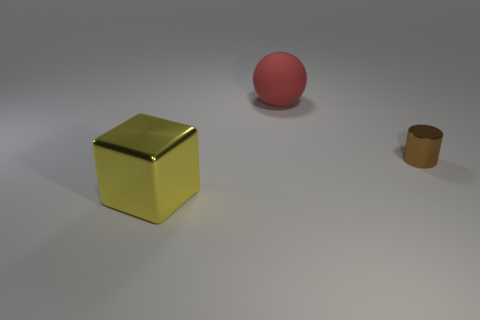Does the large block have the same material as the brown cylinder?
Make the answer very short. Yes. Are there any big rubber objects that are behind the large thing behind the metal block?
Your answer should be very brief. No. Are there any tiny yellow matte objects of the same shape as the red object?
Your answer should be compact. No. Does the cube have the same color as the rubber ball?
Provide a succinct answer. No. What material is the large object in front of the shiny thing that is on the right side of the large yellow metallic thing?
Offer a very short reply. Metal. What size is the red matte sphere?
Ensure brevity in your answer.  Large. What is the size of the cylinder that is the same material as the large cube?
Offer a terse response. Small. Is the size of the shiny object right of the yellow thing the same as the rubber ball?
Your response must be concise. No. The metal thing that is behind the metal thing that is in front of the small brown metallic thing on the right side of the matte sphere is what shape?
Give a very brief answer. Cylinder. What number of things are yellow shiny cubes or metal things on the right side of the big yellow block?
Provide a succinct answer. 2. 